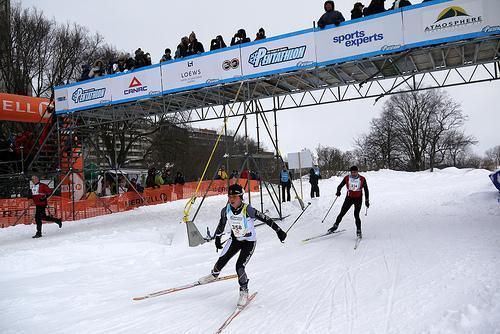How many skiers are there?
Give a very brief answer. 2. 